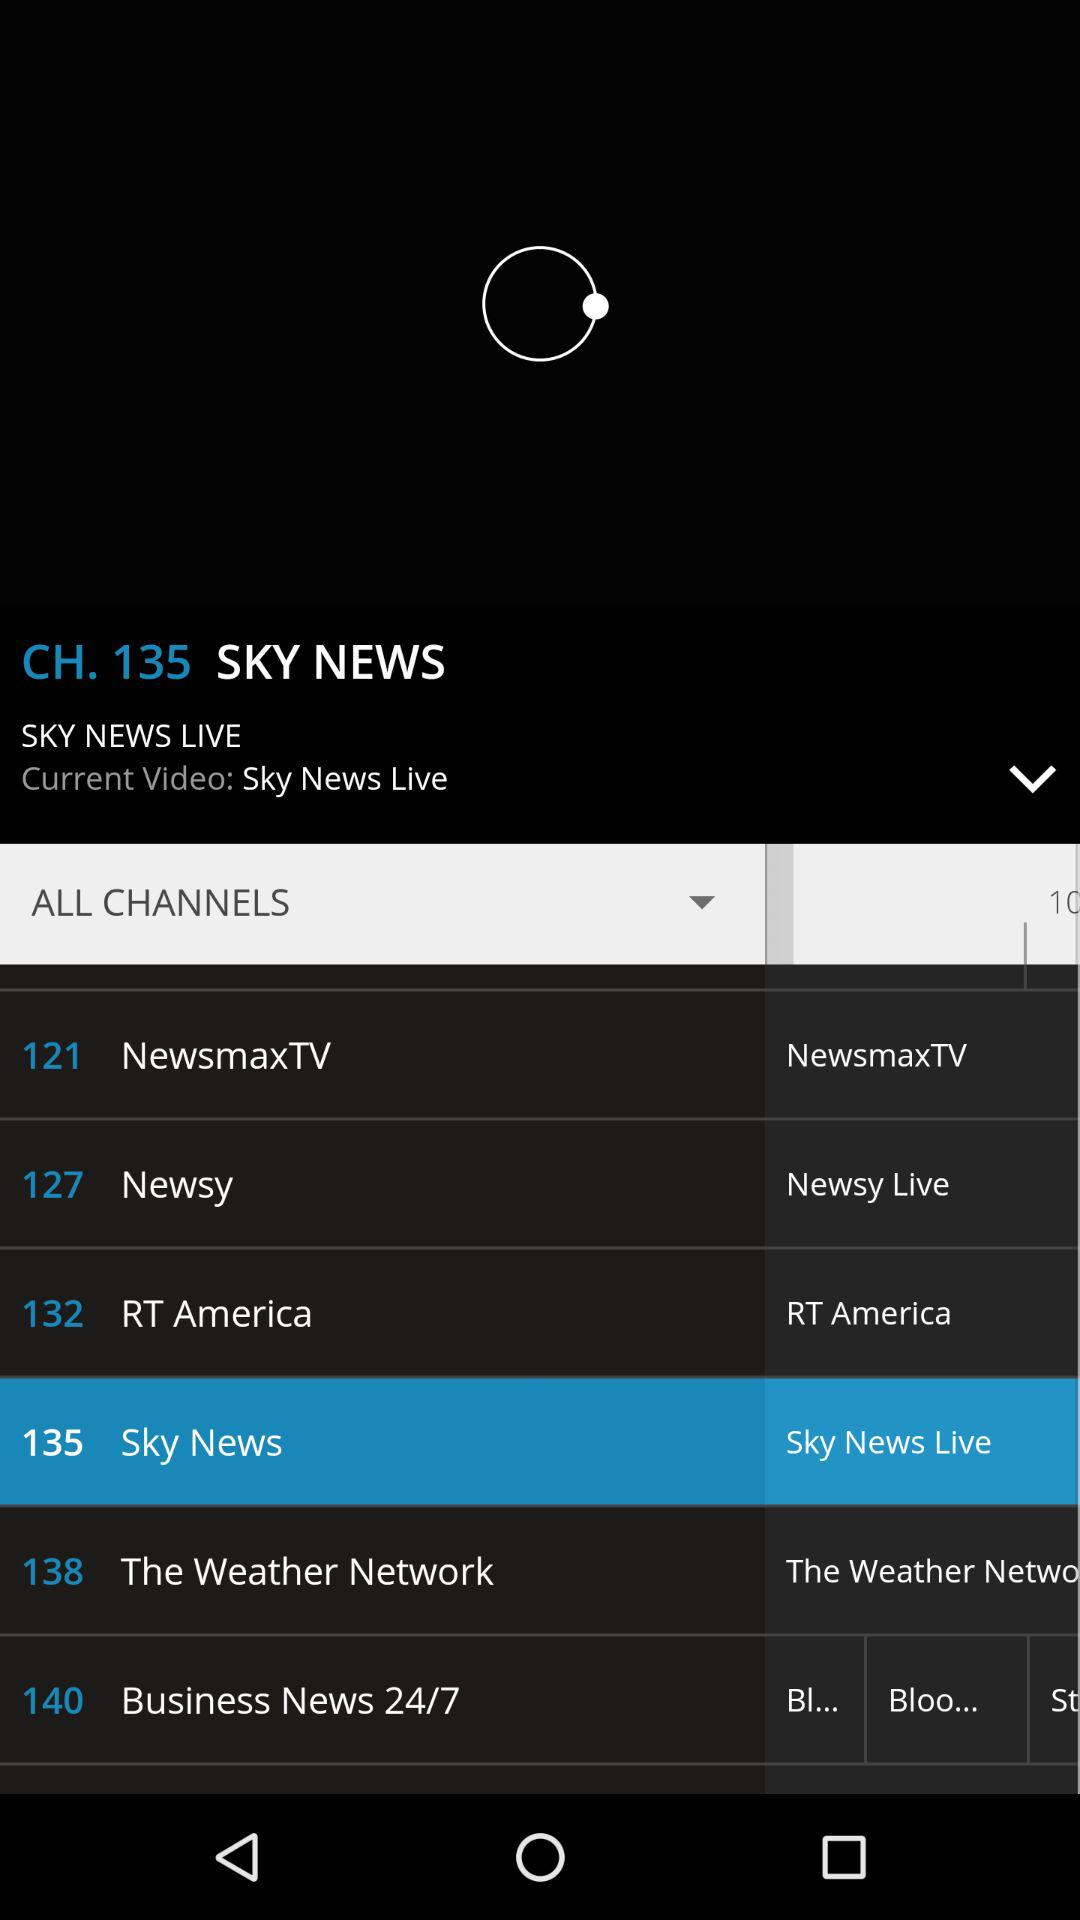What is the channel number of "Newsy"? The channel number of "Newsy" is 127. 